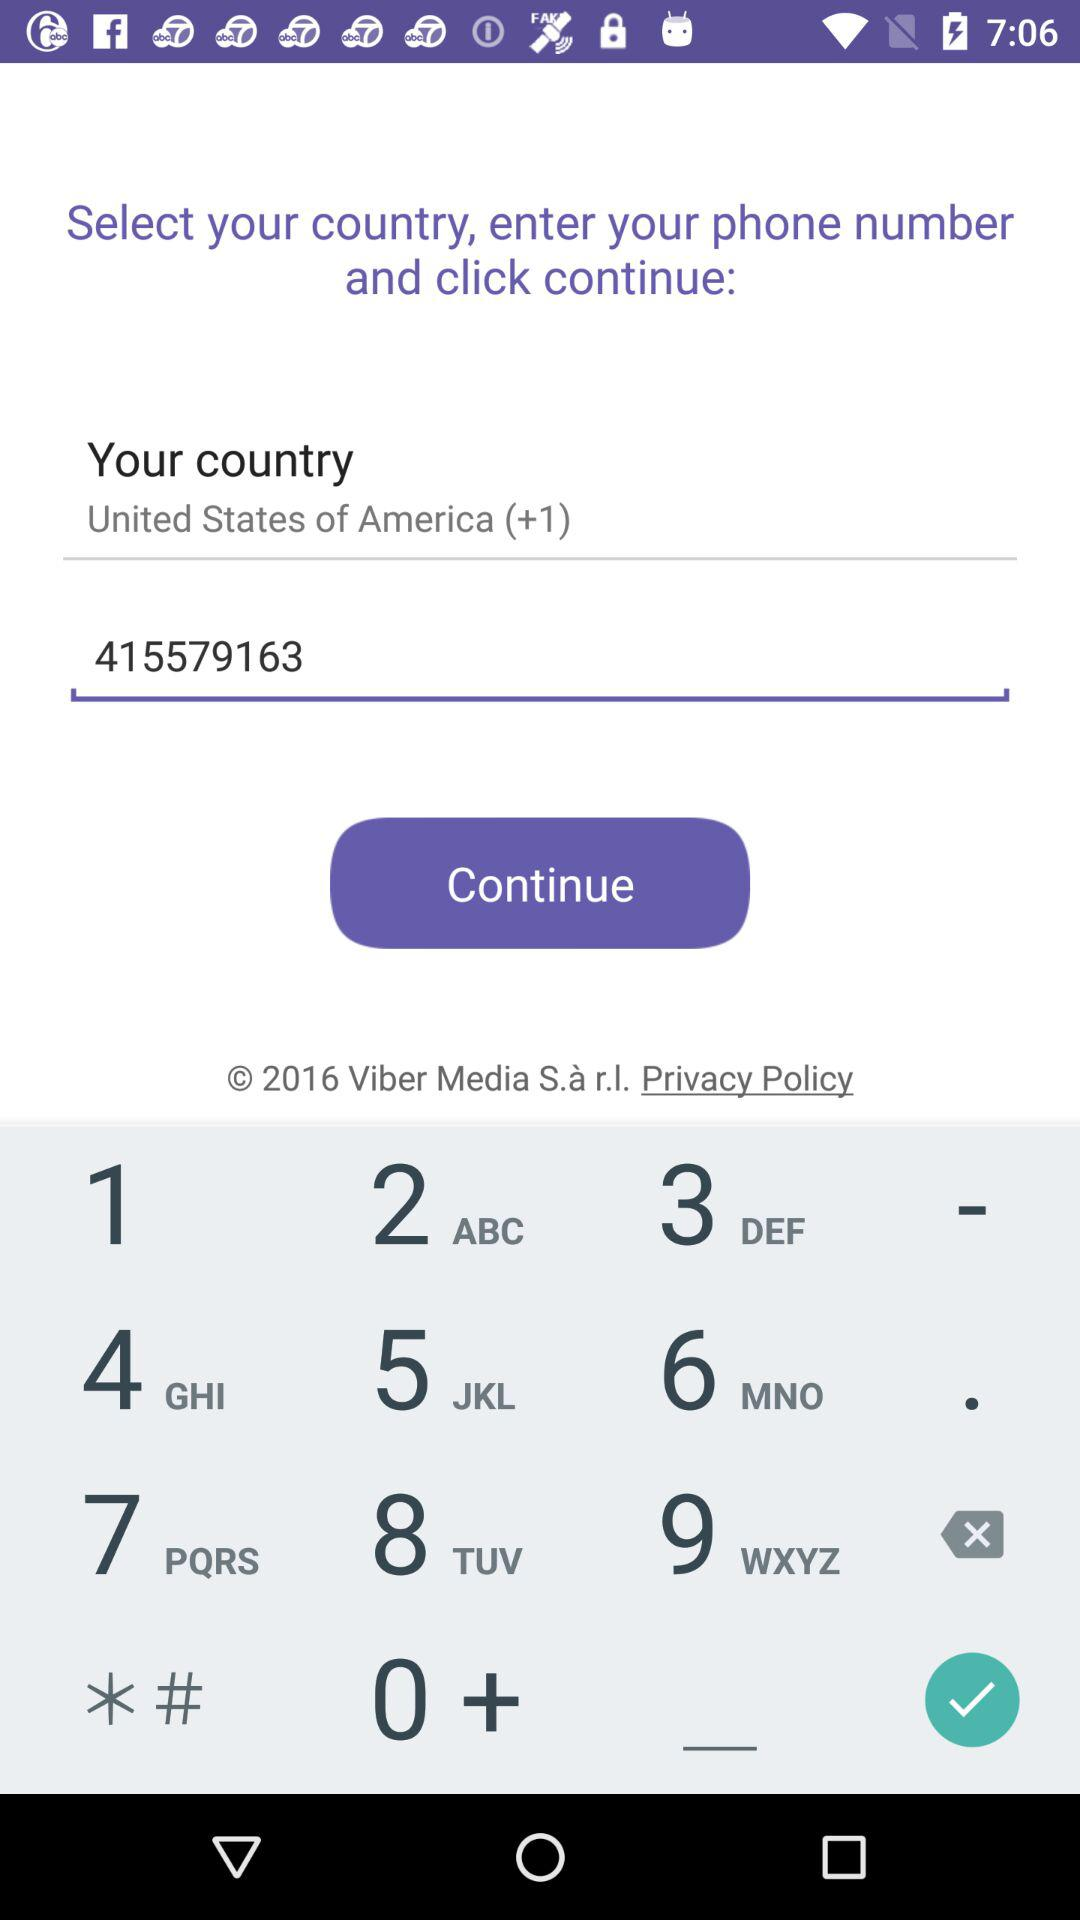What's the phone number? The phone number is 415579163. 